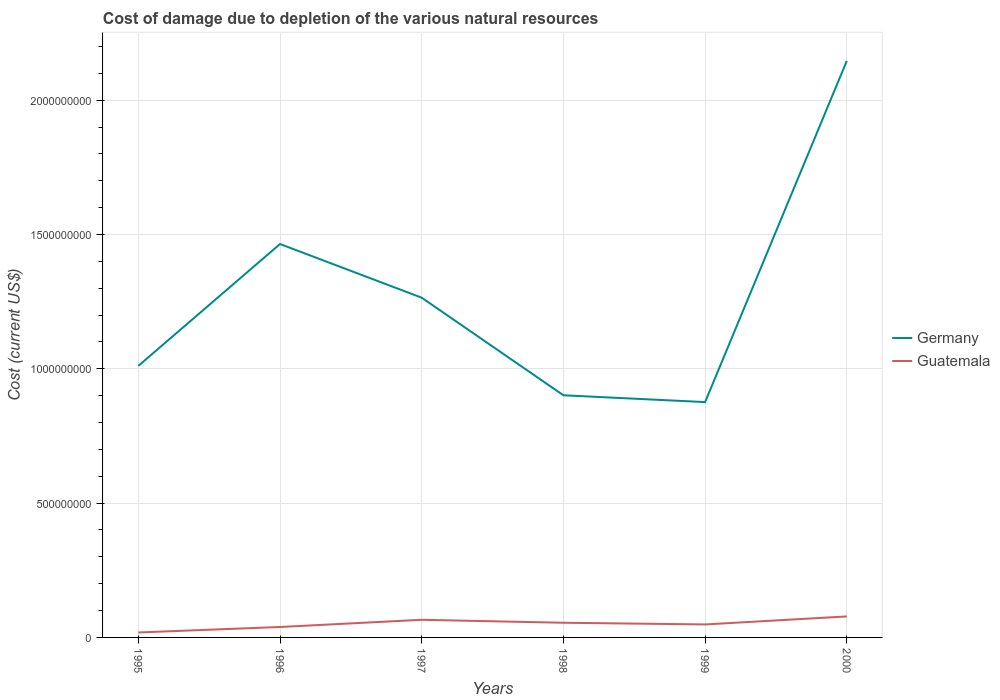Across all years, what is the maximum cost of damage caused due to the depletion of various natural resources in Guatemala?
Keep it short and to the point. 1.85e+07. In which year was the cost of damage caused due to the depletion of various natural resources in Guatemala maximum?
Your response must be concise. 1995. What is the total cost of damage caused due to the depletion of various natural resources in Guatemala in the graph?
Make the answer very short. -2.98e+07. What is the difference between the highest and the second highest cost of damage caused due to the depletion of various natural resources in Guatemala?
Provide a succinct answer. 5.97e+07. How many lines are there?
Your answer should be very brief. 2. What is the difference between two consecutive major ticks on the Y-axis?
Ensure brevity in your answer.  5.00e+08. Where does the legend appear in the graph?
Your response must be concise. Center right. How are the legend labels stacked?
Provide a succinct answer. Vertical. What is the title of the graph?
Provide a succinct answer. Cost of damage due to depletion of the various natural resources. What is the label or title of the Y-axis?
Keep it short and to the point. Cost (current US$). What is the Cost (current US$) of Germany in 1995?
Offer a terse response. 1.01e+09. What is the Cost (current US$) in Guatemala in 1995?
Offer a terse response. 1.85e+07. What is the Cost (current US$) of Germany in 1996?
Provide a succinct answer. 1.46e+09. What is the Cost (current US$) of Guatemala in 1996?
Your answer should be compact. 3.89e+07. What is the Cost (current US$) in Germany in 1997?
Give a very brief answer. 1.26e+09. What is the Cost (current US$) in Guatemala in 1997?
Make the answer very short. 6.56e+07. What is the Cost (current US$) of Germany in 1998?
Make the answer very short. 9.02e+08. What is the Cost (current US$) of Guatemala in 1998?
Give a very brief answer. 5.47e+07. What is the Cost (current US$) in Germany in 1999?
Make the answer very short. 8.76e+08. What is the Cost (current US$) of Guatemala in 1999?
Give a very brief answer. 4.83e+07. What is the Cost (current US$) of Germany in 2000?
Provide a short and direct response. 2.15e+09. What is the Cost (current US$) of Guatemala in 2000?
Ensure brevity in your answer.  7.82e+07. Across all years, what is the maximum Cost (current US$) in Germany?
Keep it short and to the point. 2.15e+09. Across all years, what is the maximum Cost (current US$) in Guatemala?
Provide a short and direct response. 7.82e+07. Across all years, what is the minimum Cost (current US$) in Germany?
Keep it short and to the point. 8.76e+08. Across all years, what is the minimum Cost (current US$) in Guatemala?
Provide a succinct answer. 1.85e+07. What is the total Cost (current US$) in Germany in the graph?
Your response must be concise. 7.66e+09. What is the total Cost (current US$) of Guatemala in the graph?
Your response must be concise. 3.04e+08. What is the difference between the Cost (current US$) in Germany in 1995 and that in 1996?
Ensure brevity in your answer.  -4.54e+08. What is the difference between the Cost (current US$) of Guatemala in 1995 and that in 1996?
Provide a short and direct response. -2.04e+07. What is the difference between the Cost (current US$) in Germany in 1995 and that in 1997?
Your response must be concise. -2.54e+08. What is the difference between the Cost (current US$) in Guatemala in 1995 and that in 1997?
Your answer should be very brief. -4.72e+07. What is the difference between the Cost (current US$) of Germany in 1995 and that in 1998?
Your answer should be compact. 1.09e+08. What is the difference between the Cost (current US$) of Guatemala in 1995 and that in 1998?
Give a very brief answer. -3.62e+07. What is the difference between the Cost (current US$) in Germany in 1995 and that in 1999?
Provide a succinct answer. 1.35e+08. What is the difference between the Cost (current US$) of Guatemala in 1995 and that in 1999?
Give a very brief answer. -2.99e+07. What is the difference between the Cost (current US$) in Germany in 1995 and that in 2000?
Your response must be concise. -1.14e+09. What is the difference between the Cost (current US$) of Guatemala in 1995 and that in 2000?
Your answer should be compact. -5.97e+07. What is the difference between the Cost (current US$) in Germany in 1996 and that in 1997?
Your response must be concise. 2.00e+08. What is the difference between the Cost (current US$) of Guatemala in 1996 and that in 1997?
Provide a short and direct response. -2.68e+07. What is the difference between the Cost (current US$) in Germany in 1996 and that in 1998?
Your answer should be compact. 5.63e+08. What is the difference between the Cost (current US$) in Guatemala in 1996 and that in 1998?
Your response must be concise. -1.58e+07. What is the difference between the Cost (current US$) in Germany in 1996 and that in 1999?
Your answer should be compact. 5.88e+08. What is the difference between the Cost (current US$) of Guatemala in 1996 and that in 1999?
Your response must be concise. -9.44e+06. What is the difference between the Cost (current US$) of Germany in 1996 and that in 2000?
Your response must be concise. -6.82e+08. What is the difference between the Cost (current US$) of Guatemala in 1996 and that in 2000?
Provide a short and direct response. -3.93e+07. What is the difference between the Cost (current US$) in Germany in 1997 and that in 1998?
Ensure brevity in your answer.  3.63e+08. What is the difference between the Cost (current US$) of Guatemala in 1997 and that in 1998?
Your response must be concise. 1.10e+07. What is the difference between the Cost (current US$) in Germany in 1997 and that in 1999?
Offer a very short reply. 3.89e+08. What is the difference between the Cost (current US$) of Guatemala in 1997 and that in 1999?
Your answer should be very brief. 1.73e+07. What is the difference between the Cost (current US$) of Germany in 1997 and that in 2000?
Make the answer very short. -8.82e+08. What is the difference between the Cost (current US$) of Guatemala in 1997 and that in 2000?
Ensure brevity in your answer.  -1.25e+07. What is the difference between the Cost (current US$) of Germany in 1998 and that in 1999?
Your response must be concise. 2.54e+07. What is the difference between the Cost (current US$) of Guatemala in 1998 and that in 1999?
Your answer should be very brief. 6.34e+06. What is the difference between the Cost (current US$) in Germany in 1998 and that in 2000?
Give a very brief answer. -1.25e+09. What is the difference between the Cost (current US$) of Guatemala in 1998 and that in 2000?
Provide a short and direct response. -2.35e+07. What is the difference between the Cost (current US$) in Germany in 1999 and that in 2000?
Your answer should be very brief. -1.27e+09. What is the difference between the Cost (current US$) in Guatemala in 1999 and that in 2000?
Offer a very short reply. -2.98e+07. What is the difference between the Cost (current US$) of Germany in 1995 and the Cost (current US$) of Guatemala in 1996?
Provide a short and direct response. 9.72e+08. What is the difference between the Cost (current US$) of Germany in 1995 and the Cost (current US$) of Guatemala in 1997?
Your response must be concise. 9.45e+08. What is the difference between the Cost (current US$) of Germany in 1995 and the Cost (current US$) of Guatemala in 1998?
Ensure brevity in your answer.  9.56e+08. What is the difference between the Cost (current US$) of Germany in 1995 and the Cost (current US$) of Guatemala in 1999?
Provide a short and direct response. 9.63e+08. What is the difference between the Cost (current US$) of Germany in 1995 and the Cost (current US$) of Guatemala in 2000?
Keep it short and to the point. 9.33e+08. What is the difference between the Cost (current US$) of Germany in 1996 and the Cost (current US$) of Guatemala in 1997?
Keep it short and to the point. 1.40e+09. What is the difference between the Cost (current US$) in Germany in 1996 and the Cost (current US$) in Guatemala in 1998?
Ensure brevity in your answer.  1.41e+09. What is the difference between the Cost (current US$) of Germany in 1996 and the Cost (current US$) of Guatemala in 1999?
Provide a short and direct response. 1.42e+09. What is the difference between the Cost (current US$) in Germany in 1996 and the Cost (current US$) in Guatemala in 2000?
Offer a terse response. 1.39e+09. What is the difference between the Cost (current US$) in Germany in 1997 and the Cost (current US$) in Guatemala in 1998?
Make the answer very short. 1.21e+09. What is the difference between the Cost (current US$) of Germany in 1997 and the Cost (current US$) of Guatemala in 1999?
Offer a very short reply. 1.22e+09. What is the difference between the Cost (current US$) of Germany in 1997 and the Cost (current US$) of Guatemala in 2000?
Keep it short and to the point. 1.19e+09. What is the difference between the Cost (current US$) in Germany in 1998 and the Cost (current US$) in Guatemala in 1999?
Your answer should be compact. 8.53e+08. What is the difference between the Cost (current US$) of Germany in 1998 and the Cost (current US$) of Guatemala in 2000?
Offer a terse response. 8.23e+08. What is the difference between the Cost (current US$) of Germany in 1999 and the Cost (current US$) of Guatemala in 2000?
Your answer should be very brief. 7.98e+08. What is the average Cost (current US$) of Germany per year?
Your answer should be compact. 1.28e+09. What is the average Cost (current US$) of Guatemala per year?
Provide a succinct answer. 5.07e+07. In the year 1995, what is the difference between the Cost (current US$) in Germany and Cost (current US$) in Guatemala?
Give a very brief answer. 9.92e+08. In the year 1996, what is the difference between the Cost (current US$) in Germany and Cost (current US$) in Guatemala?
Give a very brief answer. 1.43e+09. In the year 1997, what is the difference between the Cost (current US$) of Germany and Cost (current US$) of Guatemala?
Offer a very short reply. 1.20e+09. In the year 1998, what is the difference between the Cost (current US$) of Germany and Cost (current US$) of Guatemala?
Offer a very short reply. 8.47e+08. In the year 1999, what is the difference between the Cost (current US$) in Germany and Cost (current US$) in Guatemala?
Provide a succinct answer. 8.28e+08. In the year 2000, what is the difference between the Cost (current US$) in Germany and Cost (current US$) in Guatemala?
Your answer should be compact. 2.07e+09. What is the ratio of the Cost (current US$) in Germany in 1995 to that in 1996?
Offer a terse response. 0.69. What is the ratio of the Cost (current US$) of Guatemala in 1995 to that in 1996?
Give a very brief answer. 0.47. What is the ratio of the Cost (current US$) in Germany in 1995 to that in 1997?
Provide a succinct answer. 0.8. What is the ratio of the Cost (current US$) of Guatemala in 1995 to that in 1997?
Make the answer very short. 0.28. What is the ratio of the Cost (current US$) of Germany in 1995 to that in 1998?
Ensure brevity in your answer.  1.12. What is the ratio of the Cost (current US$) in Guatemala in 1995 to that in 1998?
Offer a very short reply. 0.34. What is the ratio of the Cost (current US$) of Germany in 1995 to that in 1999?
Give a very brief answer. 1.15. What is the ratio of the Cost (current US$) in Guatemala in 1995 to that in 1999?
Provide a succinct answer. 0.38. What is the ratio of the Cost (current US$) in Germany in 1995 to that in 2000?
Your answer should be compact. 0.47. What is the ratio of the Cost (current US$) of Guatemala in 1995 to that in 2000?
Give a very brief answer. 0.24. What is the ratio of the Cost (current US$) in Germany in 1996 to that in 1997?
Offer a terse response. 1.16. What is the ratio of the Cost (current US$) in Guatemala in 1996 to that in 1997?
Make the answer very short. 0.59. What is the ratio of the Cost (current US$) of Germany in 1996 to that in 1998?
Your answer should be very brief. 1.62. What is the ratio of the Cost (current US$) of Guatemala in 1996 to that in 1998?
Your response must be concise. 0.71. What is the ratio of the Cost (current US$) in Germany in 1996 to that in 1999?
Provide a succinct answer. 1.67. What is the ratio of the Cost (current US$) of Guatemala in 1996 to that in 1999?
Your answer should be compact. 0.8. What is the ratio of the Cost (current US$) in Germany in 1996 to that in 2000?
Your response must be concise. 0.68. What is the ratio of the Cost (current US$) of Guatemala in 1996 to that in 2000?
Provide a short and direct response. 0.5. What is the ratio of the Cost (current US$) in Germany in 1997 to that in 1998?
Make the answer very short. 1.4. What is the ratio of the Cost (current US$) of Guatemala in 1997 to that in 1998?
Offer a very short reply. 1.2. What is the ratio of the Cost (current US$) in Germany in 1997 to that in 1999?
Provide a succinct answer. 1.44. What is the ratio of the Cost (current US$) of Guatemala in 1997 to that in 1999?
Make the answer very short. 1.36. What is the ratio of the Cost (current US$) of Germany in 1997 to that in 2000?
Your answer should be very brief. 0.59. What is the ratio of the Cost (current US$) in Guatemala in 1997 to that in 2000?
Give a very brief answer. 0.84. What is the ratio of the Cost (current US$) of Guatemala in 1998 to that in 1999?
Offer a terse response. 1.13. What is the ratio of the Cost (current US$) in Germany in 1998 to that in 2000?
Your answer should be compact. 0.42. What is the ratio of the Cost (current US$) of Guatemala in 1998 to that in 2000?
Provide a succinct answer. 0.7. What is the ratio of the Cost (current US$) in Germany in 1999 to that in 2000?
Offer a very short reply. 0.41. What is the ratio of the Cost (current US$) in Guatemala in 1999 to that in 2000?
Provide a short and direct response. 0.62. What is the difference between the highest and the second highest Cost (current US$) of Germany?
Offer a terse response. 6.82e+08. What is the difference between the highest and the second highest Cost (current US$) of Guatemala?
Give a very brief answer. 1.25e+07. What is the difference between the highest and the lowest Cost (current US$) in Germany?
Keep it short and to the point. 1.27e+09. What is the difference between the highest and the lowest Cost (current US$) in Guatemala?
Ensure brevity in your answer.  5.97e+07. 